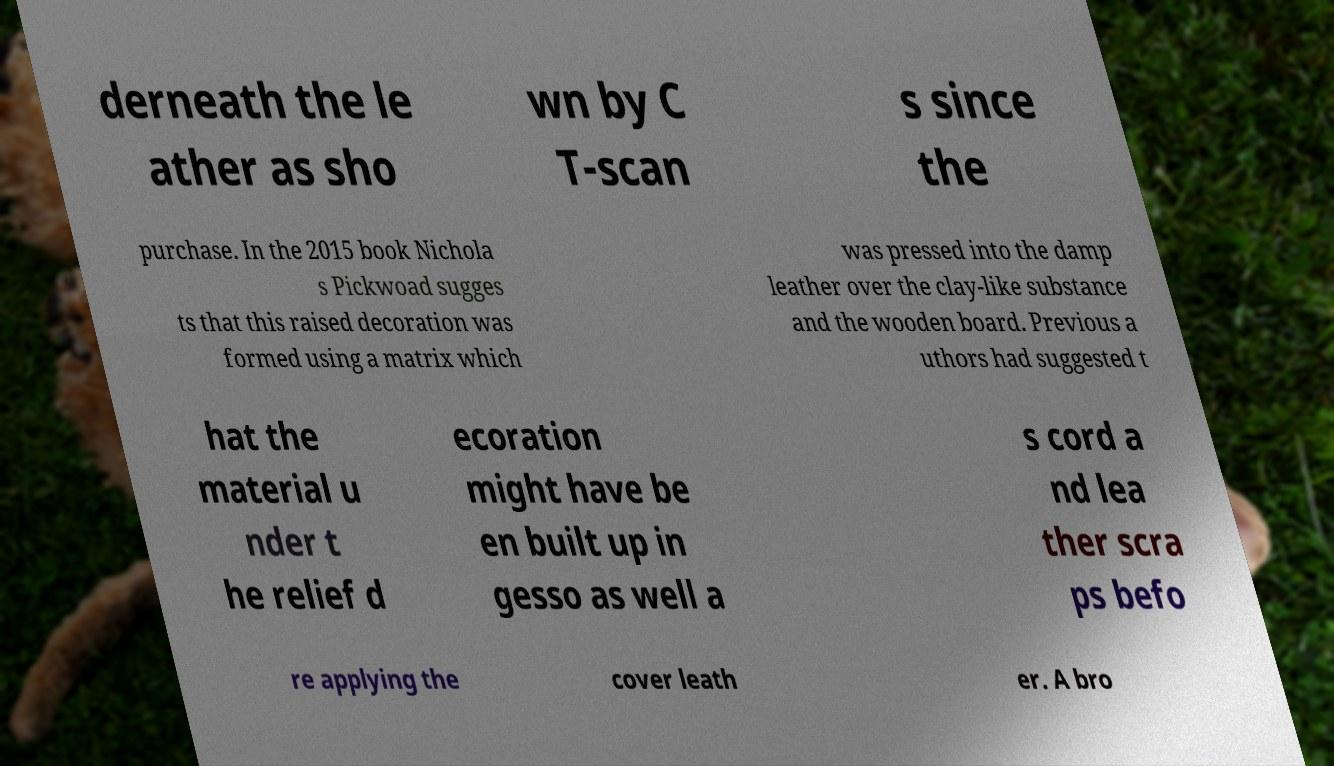There's text embedded in this image that I need extracted. Can you transcribe it verbatim? derneath the le ather as sho wn by C T-scan s since the purchase. In the 2015 book Nichola s Pickwoad sugges ts that this raised decoration was formed using a matrix which was pressed into the damp leather over the clay-like substance and the wooden board. Previous a uthors had suggested t hat the material u nder t he relief d ecoration might have be en built up in gesso as well a s cord a nd lea ther scra ps befo re applying the cover leath er. A bro 